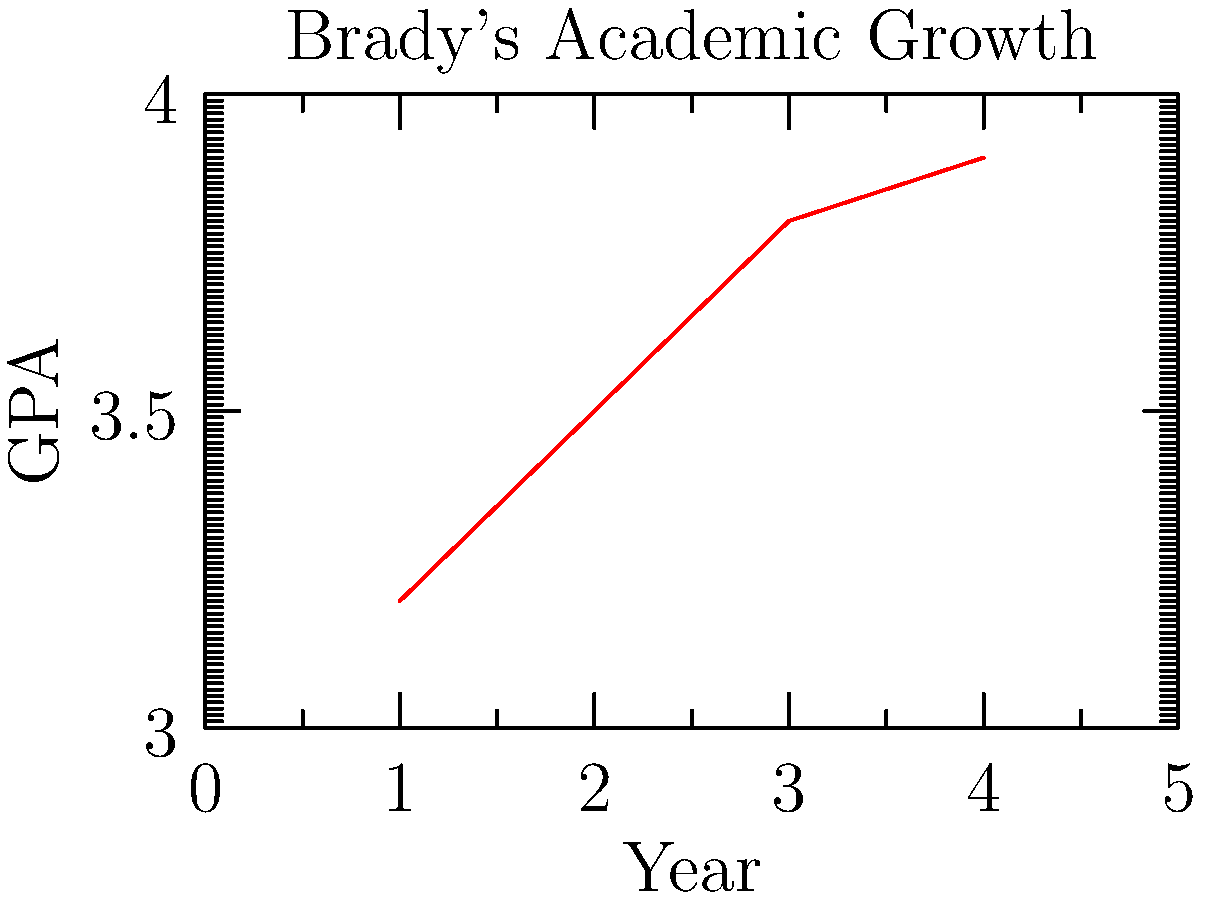Based on the line graph showing Brady's academic growth over four years, what was his approximate GPA improvement from Year 1 to Year 4? To determine Brady's GPA improvement from Year 1 to Year 4, we need to:

1. Identify the GPA for Year 1:
   From the graph, we can see that Brady's GPA in Year 1 was approximately 3.2.

2. Identify the GPA for Year 4:
   The graph shows that Brady's GPA in Year 4 was approximately 3.9.

3. Calculate the difference:
   GPA improvement = Year 4 GPA - Year 1 GPA
   $$ 3.9 - 3.2 = 0.7 $$

Therefore, Brady's GPA improved by approximately 0.7 points from Year 1 to Year 4.
Answer: 0.7 